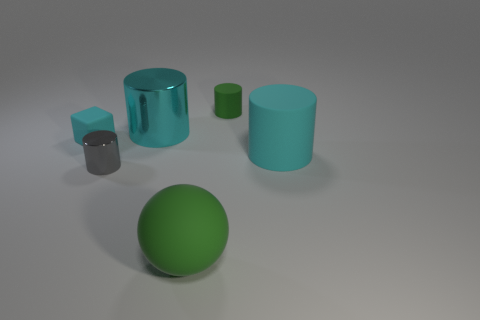Add 3 yellow rubber blocks. How many objects exist? 9 Subtract all cylinders. How many objects are left? 2 Subtract all gray things. Subtract all green matte things. How many objects are left? 3 Add 2 small things. How many small things are left? 5 Add 4 green objects. How many green objects exist? 6 Subtract 0 blue spheres. How many objects are left? 6 